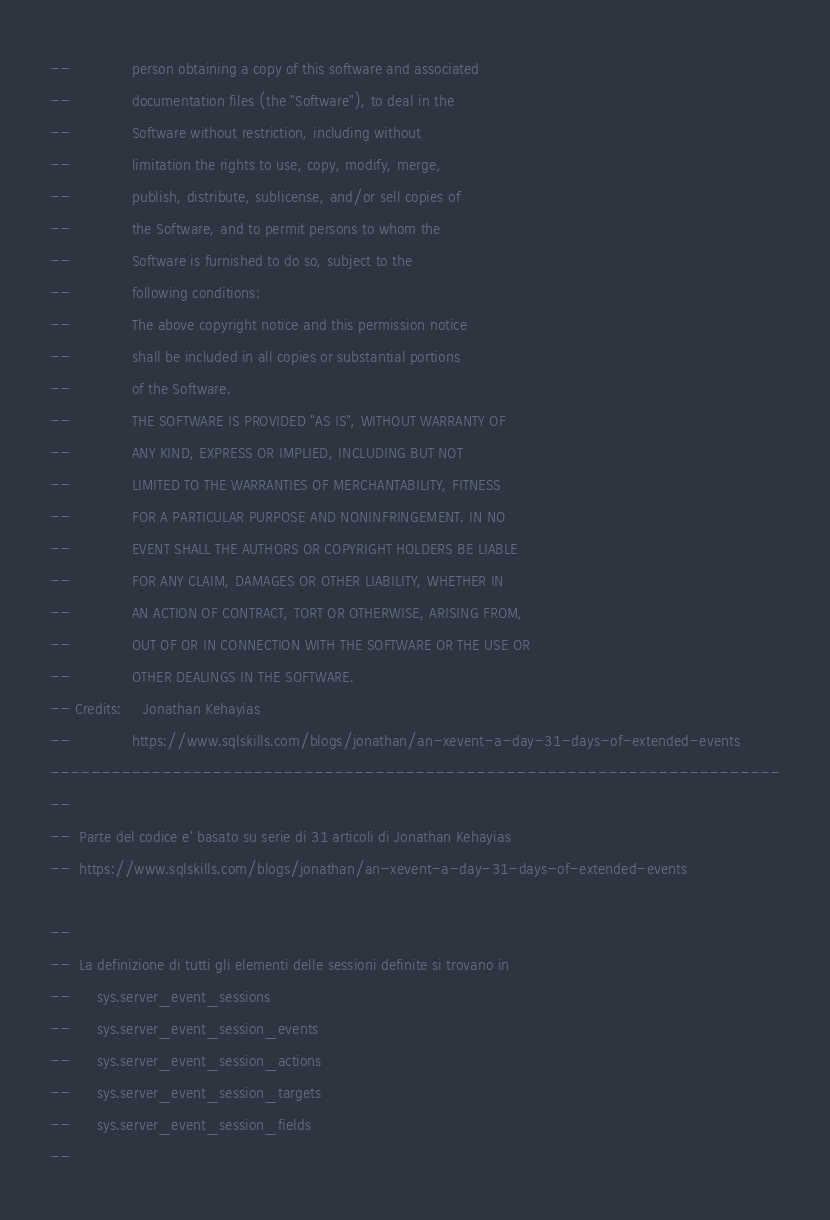Convert code to text. <code><loc_0><loc_0><loc_500><loc_500><_SQL_>--              person obtaining a copy of this software and associated
--              documentation files (the "Software"), to deal in the
--              Software without restriction, including without
--              limitation the rights to use, copy, modify, merge,
--              publish, distribute, sublicense, and/or sell copies of
--              the Software, and to permit persons to whom the
--              Software is furnished to do so, subject to the
--              following conditions:
--              The above copyright notice and this permission notice
--              shall be included in all copies or substantial portions
--              of the Software.
--              THE SOFTWARE IS PROVIDED "AS IS", WITHOUT WARRANTY OF
--              ANY KIND, EXPRESS OR IMPLIED, INCLUDING BUT NOT
--              LIMITED TO THE WARRANTIES OF MERCHANTABILITY, FITNESS
--              FOR A PARTICULAR PURPOSE AND NONINFRINGEMENT. IN NO
--              EVENT SHALL THE AUTHORS OR COPYRIGHT HOLDERS BE LIABLE
--              FOR ANY CLAIM, DAMAGES OR OTHER LIABILITY, WHETHER IN
--              AN ACTION OF CONTRACT, TORT OR OTHERWISE, ARISING FROM,
--              OUT OF OR IN CONNECTION WITH THE SOFTWARE OR THE USE OR
--              OTHER DEALINGS IN THE SOFTWARE.
-- Credits:		Jonathan Kehayias
--              https://www.sqlskills.com/blogs/jonathan/an-xevent-a-day-31-days-of-extended-events
------------------------------------------------------------------------
--
--	Parte del codice e' basato su serie di 31 articoli di Jonathan Kehayias
--	https://www.sqlskills.com/blogs/jonathan/an-xevent-a-day-31-days-of-extended-events

--
--	La definizione di tutti gli elementi delle sessioni definite si trovano in
--		sys.server_event_sessions
--		sys.server_event_session_events
--		sys.server_event_session_actions
--		sys.server_event_session_targets
--		sys.server_event_session_fields
--</code> 